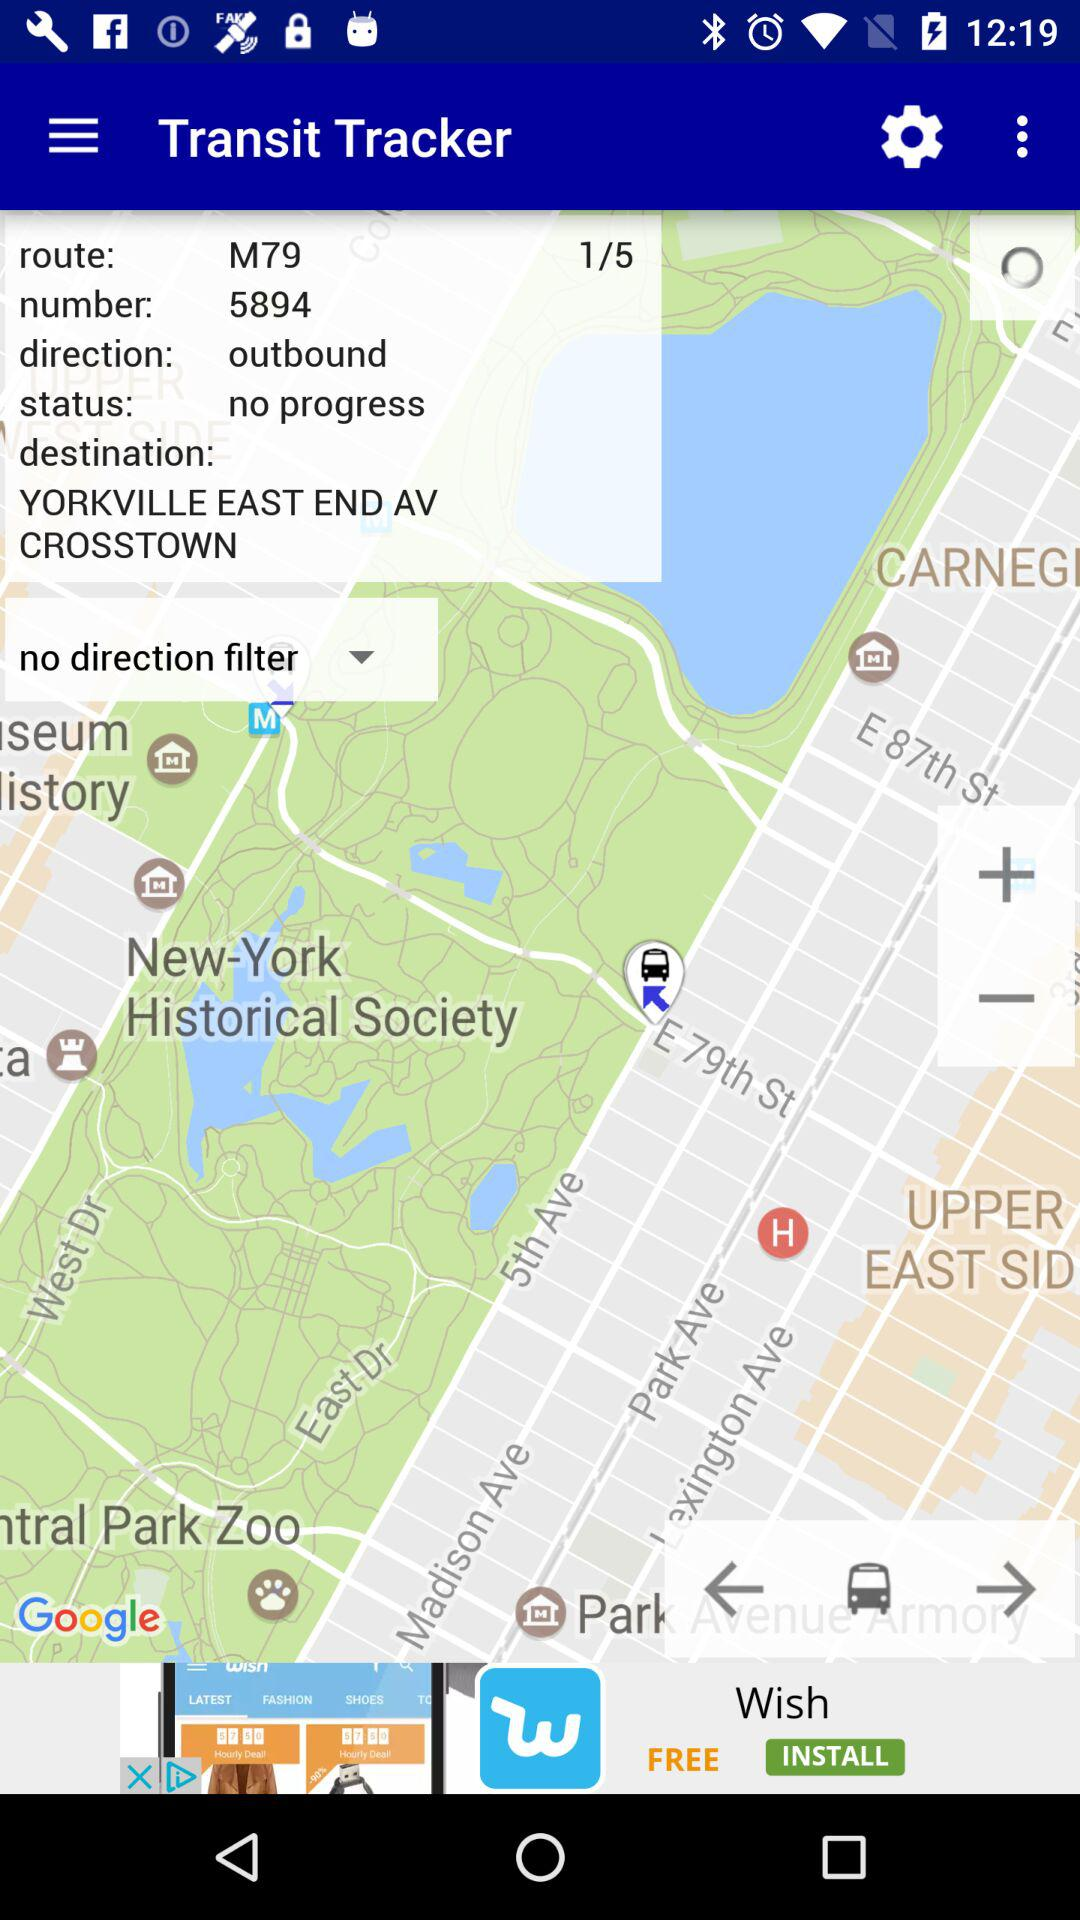Which "Transit Tracker" route are we now on? You are on route 1. 